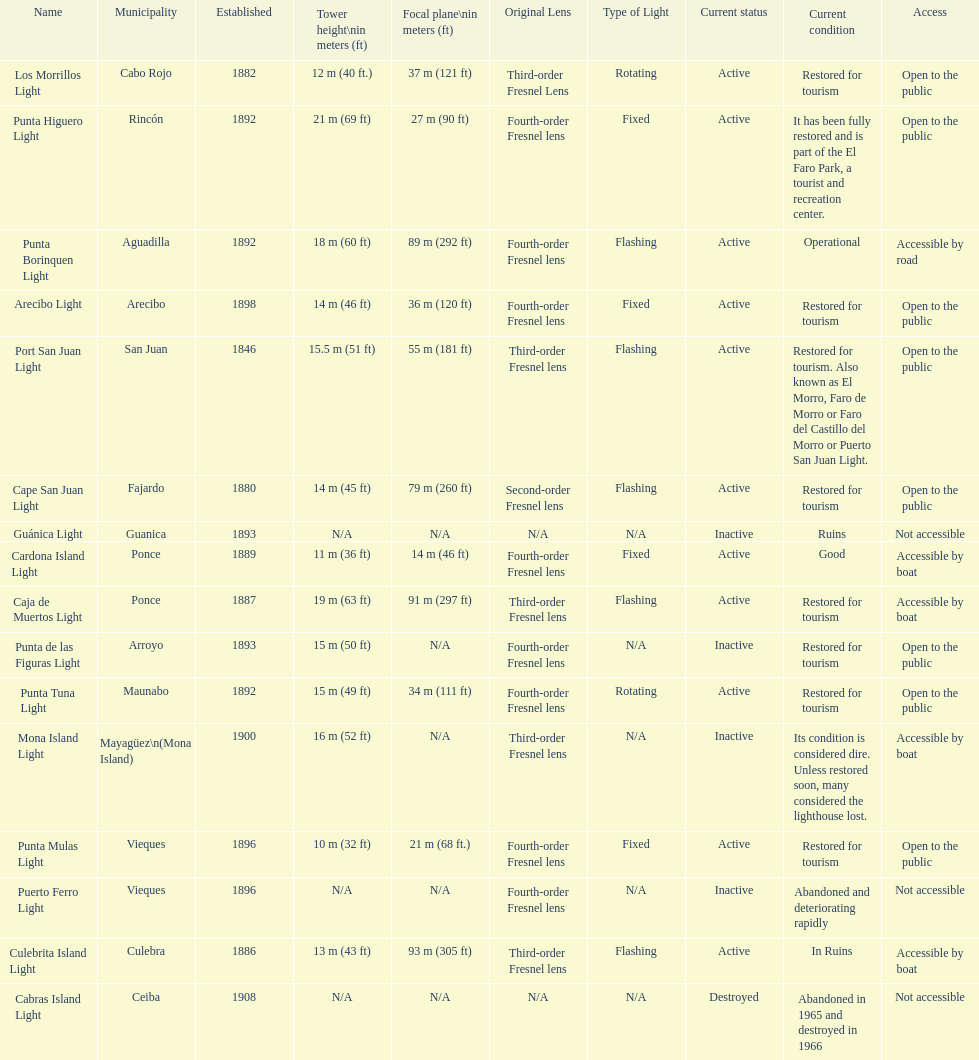Were any towers established before the year 1800? No. 